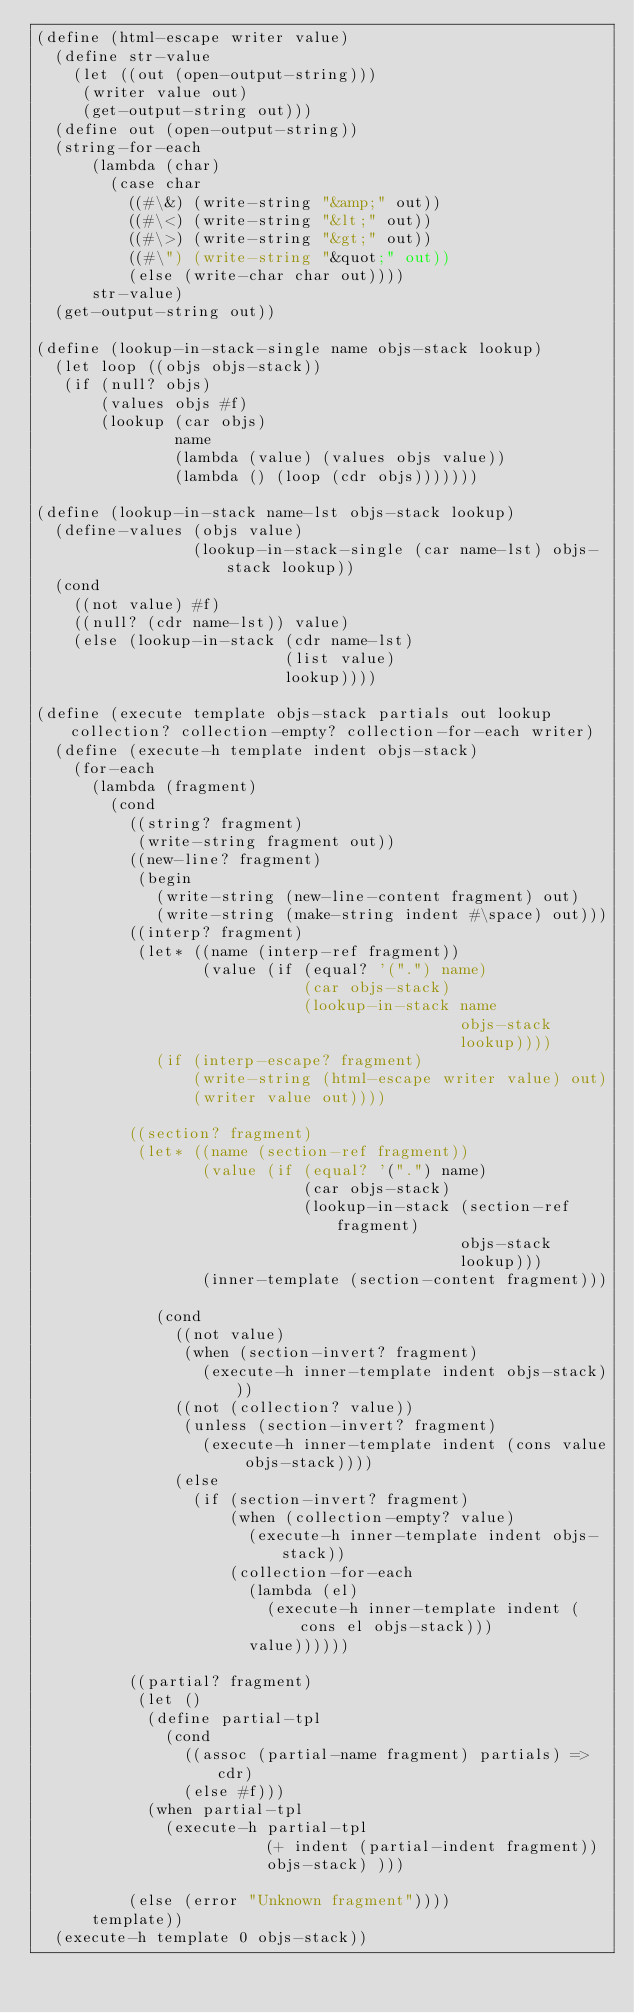Convert code to text. <code><loc_0><loc_0><loc_500><loc_500><_Scheme_>(define (html-escape writer value)
  (define str-value
    (let ((out (open-output-string)))
     (writer value out)
     (get-output-string out)))
  (define out (open-output-string))
  (string-for-each
      (lambda (char)
        (case char
          ((#\&) (write-string "&amp;" out))
          ((#\<) (write-string "&lt;" out))
          ((#\>) (write-string "&gt;" out))
          ((#\") (write-string "&quot;" out))
          (else (write-char char out))))
      str-value)
  (get-output-string out))

(define (lookup-in-stack-single name objs-stack lookup)
  (let loop ((objs objs-stack))
   (if (null? objs)
       (values objs #f)
       (lookup (car objs) 
               name
               (lambda (value) (values objs value))
               (lambda () (loop (cdr objs)))))))

(define (lookup-in-stack name-lst objs-stack lookup)
  (define-values (objs value)
                 (lookup-in-stack-single (car name-lst) objs-stack lookup))
  (cond
    ((not value) #f)
    ((null? (cdr name-lst)) value)
    (else (lookup-in-stack (cdr name-lst)
                           (list value)
                           lookup))))

(define (execute template objs-stack partials out lookup collection? collection-empty? collection-for-each writer)
  (define (execute-h template indent objs-stack)
    (for-each
      (lambda (fragment)
        (cond
          ((string? fragment)
           (write-string fragment out))
          ((new-line? fragment)
           (begin
             (write-string (new-line-content fragment) out)
             (write-string (make-string indent #\space) out)))
          ((interp? fragment)
           (let* ((name (interp-ref fragment))
                  (value (if (equal? '(".") name)
                             (car objs-stack)
                             (lookup-in-stack name
                                              objs-stack
                                              lookup))))
             (if (interp-escape? fragment)
                 (write-string (html-escape writer value) out)
                 (writer value out))))

          ((section? fragment)
           (let* ((name (section-ref fragment))
                  (value (if (equal? '(".") name)
                             (car objs-stack)
                             (lookup-in-stack (section-ref fragment)
                                              objs-stack
                                              lookup)))
                  (inner-template (section-content fragment)))
             
             (cond
               ((not value)
                (when (section-invert? fragment)
                  (execute-h inner-template indent objs-stack)))
               ((not (collection? value))
                (unless (section-invert? fragment)
                  (execute-h inner-template indent (cons value objs-stack))))
               (else
                 (if (section-invert? fragment)
                     (when (collection-empty? value)
                       (execute-h inner-template indent objs-stack))
                     (collection-for-each
                       (lambda (el)
                         (execute-h inner-template indent (cons el objs-stack)))
                       value))))))
          
          ((partial? fragment)
           (let ()
            (define partial-tpl
              (cond
                ((assoc (partial-name fragment) partials) => cdr)
                (else #f)))
            (when partial-tpl
              (execute-h partial-tpl 
                         (+ indent (partial-indent fragment))
                         objs-stack) )))
          
          (else (error "Unknown fragment"))))
      template))
  (execute-h template 0 objs-stack))
</code> 